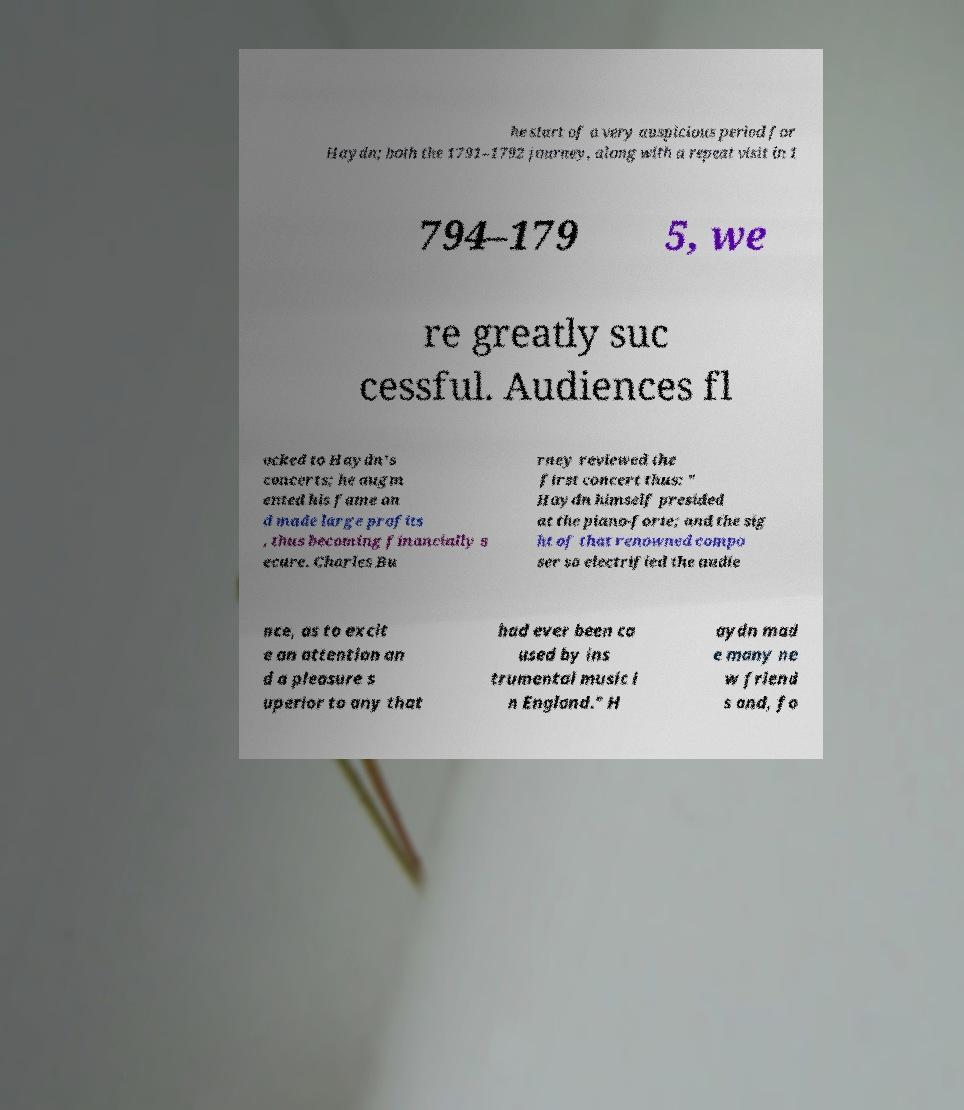I need the written content from this picture converted into text. Can you do that? he start of a very auspicious period for Haydn; both the 1791–1792 journey, along with a repeat visit in 1 794–179 5, we re greatly suc cessful. Audiences fl ocked to Haydn's concerts; he augm ented his fame an d made large profits , thus becoming financially s ecure. Charles Bu rney reviewed the first concert thus: " Haydn himself presided at the piano-forte; and the sig ht of that renowned compo ser so electrified the audie nce, as to excit e an attention an d a pleasure s uperior to any that had ever been ca used by ins trumental music i n England." H aydn mad e many ne w friend s and, fo 